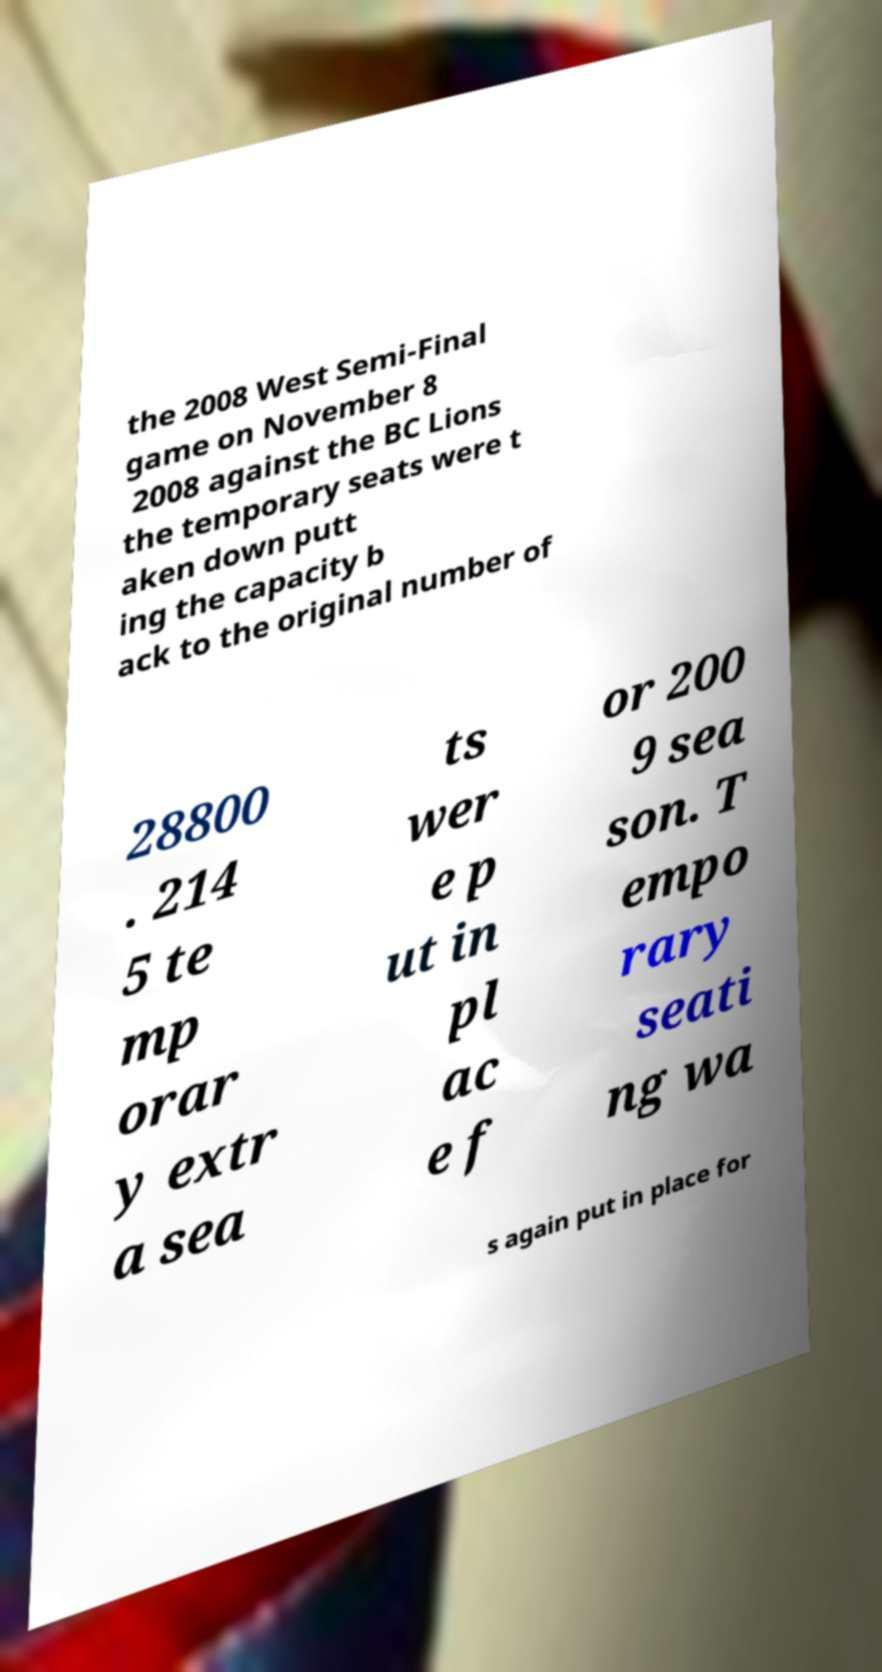Please identify and transcribe the text found in this image. the 2008 West Semi-Final game on November 8 2008 against the BC Lions the temporary seats were t aken down putt ing the capacity b ack to the original number of 28800 . 214 5 te mp orar y extr a sea ts wer e p ut in pl ac e f or 200 9 sea son. T empo rary seati ng wa s again put in place for 